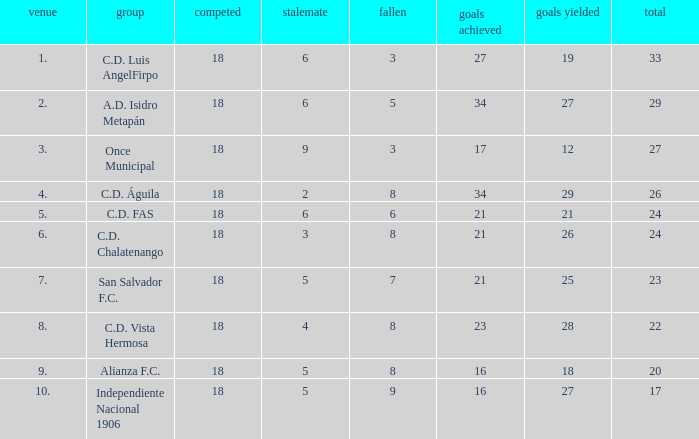What is the lowest amount of goals scored that has more than 19 goal conceded and played less than 18? None. 